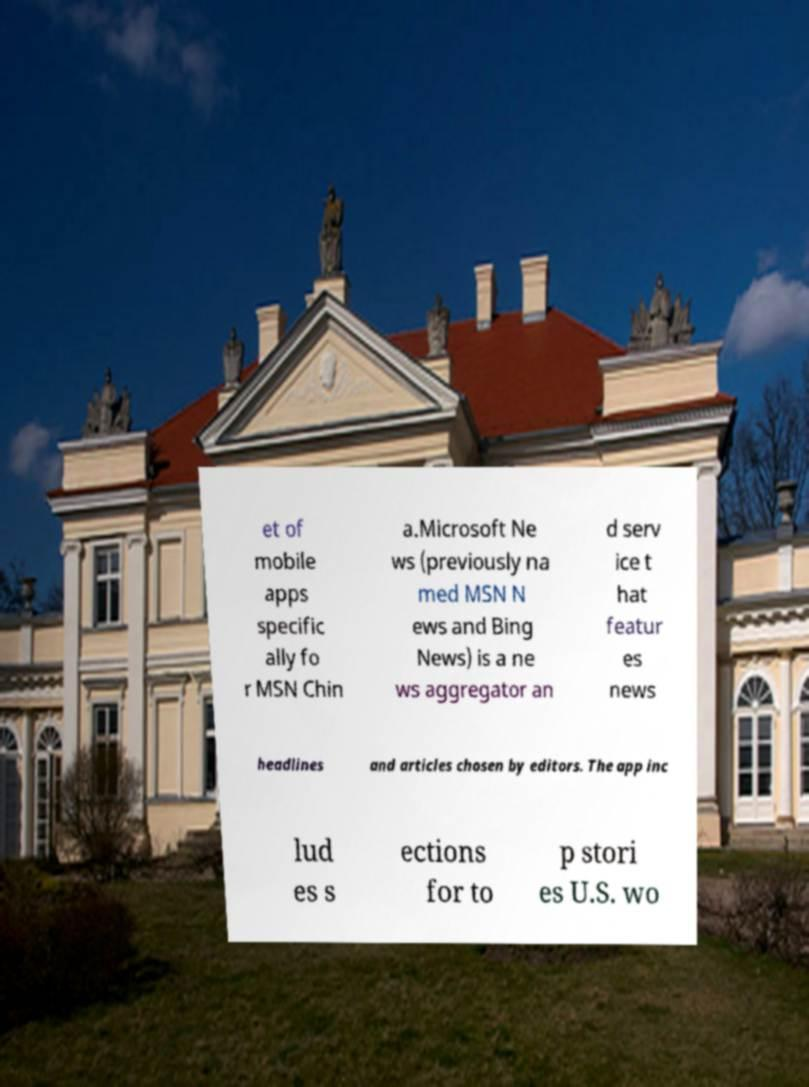For documentation purposes, I need the text within this image transcribed. Could you provide that? et of mobile apps specific ally fo r MSN Chin a.Microsoft Ne ws (previously na med MSN N ews and Bing News) is a ne ws aggregator an d serv ice t hat featur es news headlines and articles chosen by editors. The app inc lud es s ections for to p stori es U.S. wo 